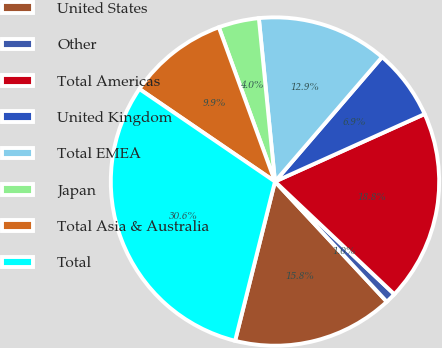Convert chart to OTSL. <chart><loc_0><loc_0><loc_500><loc_500><pie_chart><fcel>United States<fcel>Other<fcel>Total Americas<fcel>United Kingdom<fcel>Total EMEA<fcel>Japan<fcel>Total Asia & Australia<fcel>Total<nl><fcel>15.83%<fcel>1.03%<fcel>18.79%<fcel>6.95%<fcel>12.87%<fcel>3.99%<fcel>9.91%<fcel>30.63%<nl></chart> 